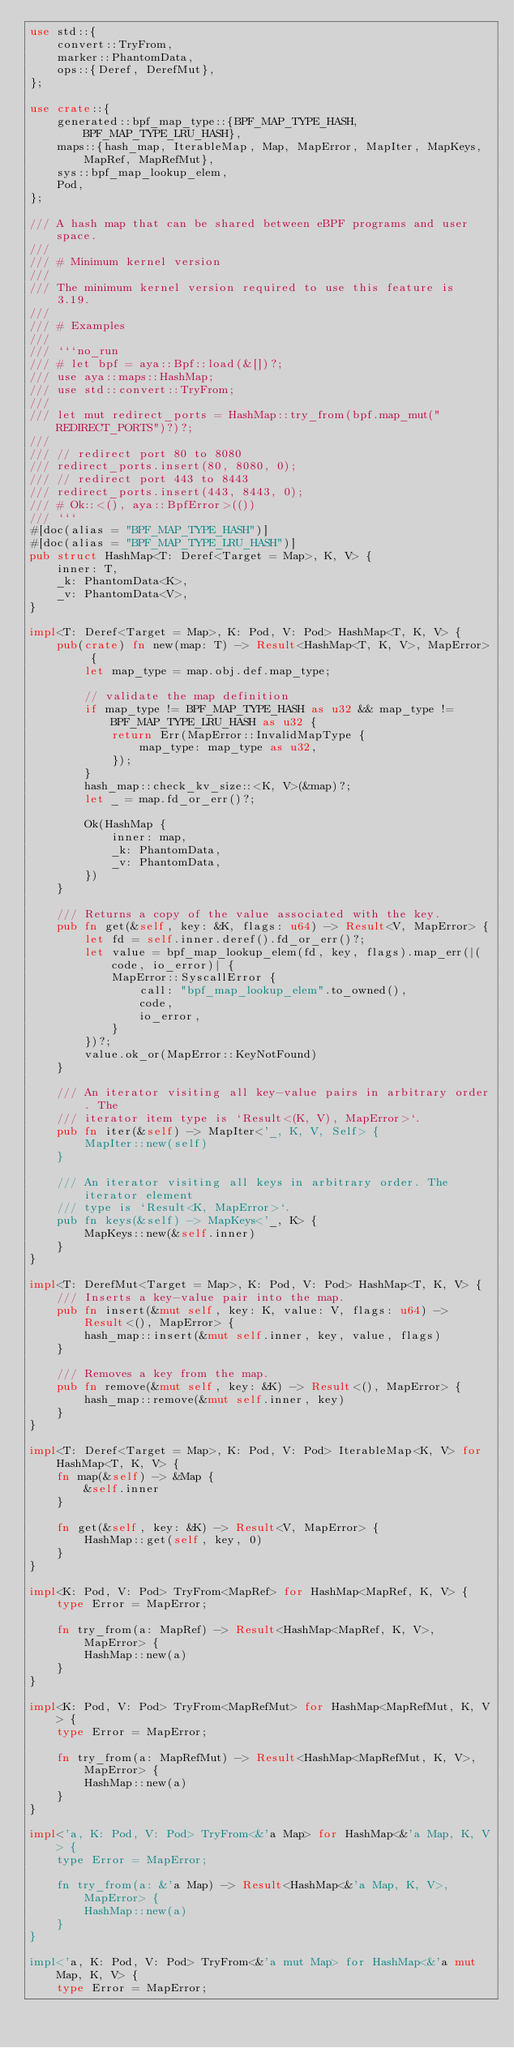Convert code to text. <code><loc_0><loc_0><loc_500><loc_500><_Rust_>use std::{
    convert::TryFrom,
    marker::PhantomData,
    ops::{Deref, DerefMut},
};

use crate::{
    generated::bpf_map_type::{BPF_MAP_TYPE_HASH, BPF_MAP_TYPE_LRU_HASH},
    maps::{hash_map, IterableMap, Map, MapError, MapIter, MapKeys, MapRef, MapRefMut},
    sys::bpf_map_lookup_elem,
    Pod,
};

/// A hash map that can be shared between eBPF programs and user space.
///
/// # Minimum kernel version
///
/// The minimum kernel version required to use this feature is 3.19.
///
/// # Examples
///
/// ```no_run
/// # let bpf = aya::Bpf::load(&[])?;
/// use aya::maps::HashMap;
/// use std::convert::TryFrom;
///
/// let mut redirect_ports = HashMap::try_from(bpf.map_mut("REDIRECT_PORTS")?)?;
///
/// // redirect port 80 to 8080
/// redirect_ports.insert(80, 8080, 0);
/// // redirect port 443 to 8443
/// redirect_ports.insert(443, 8443, 0);
/// # Ok::<(), aya::BpfError>(())
/// ```
#[doc(alias = "BPF_MAP_TYPE_HASH")]
#[doc(alias = "BPF_MAP_TYPE_LRU_HASH")]
pub struct HashMap<T: Deref<Target = Map>, K, V> {
    inner: T,
    _k: PhantomData<K>,
    _v: PhantomData<V>,
}

impl<T: Deref<Target = Map>, K: Pod, V: Pod> HashMap<T, K, V> {
    pub(crate) fn new(map: T) -> Result<HashMap<T, K, V>, MapError> {
        let map_type = map.obj.def.map_type;

        // validate the map definition
        if map_type != BPF_MAP_TYPE_HASH as u32 && map_type != BPF_MAP_TYPE_LRU_HASH as u32 {
            return Err(MapError::InvalidMapType {
                map_type: map_type as u32,
            });
        }
        hash_map::check_kv_size::<K, V>(&map)?;
        let _ = map.fd_or_err()?;

        Ok(HashMap {
            inner: map,
            _k: PhantomData,
            _v: PhantomData,
        })
    }

    /// Returns a copy of the value associated with the key.
    pub fn get(&self, key: &K, flags: u64) -> Result<V, MapError> {
        let fd = self.inner.deref().fd_or_err()?;
        let value = bpf_map_lookup_elem(fd, key, flags).map_err(|(code, io_error)| {
            MapError::SyscallError {
                call: "bpf_map_lookup_elem".to_owned(),
                code,
                io_error,
            }
        })?;
        value.ok_or(MapError::KeyNotFound)
    }

    /// An iterator visiting all key-value pairs in arbitrary order. The
    /// iterator item type is `Result<(K, V), MapError>`.
    pub fn iter(&self) -> MapIter<'_, K, V, Self> {
        MapIter::new(self)
    }

    /// An iterator visiting all keys in arbitrary order. The iterator element
    /// type is `Result<K, MapError>`.
    pub fn keys(&self) -> MapKeys<'_, K> {
        MapKeys::new(&self.inner)
    }
}

impl<T: DerefMut<Target = Map>, K: Pod, V: Pod> HashMap<T, K, V> {
    /// Inserts a key-value pair into the map.
    pub fn insert(&mut self, key: K, value: V, flags: u64) -> Result<(), MapError> {
        hash_map::insert(&mut self.inner, key, value, flags)
    }

    /// Removes a key from the map.
    pub fn remove(&mut self, key: &K) -> Result<(), MapError> {
        hash_map::remove(&mut self.inner, key)
    }
}

impl<T: Deref<Target = Map>, K: Pod, V: Pod> IterableMap<K, V> for HashMap<T, K, V> {
    fn map(&self) -> &Map {
        &self.inner
    }

    fn get(&self, key: &K) -> Result<V, MapError> {
        HashMap::get(self, key, 0)
    }
}

impl<K: Pod, V: Pod> TryFrom<MapRef> for HashMap<MapRef, K, V> {
    type Error = MapError;

    fn try_from(a: MapRef) -> Result<HashMap<MapRef, K, V>, MapError> {
        HashMap::new(a)
    }
}

impl<K: Pod, V: Pod> TryFrom<MapRefMut> for HashMap<MapRefMut, K, V> {
    type Error = MapError;

    fn try_from(a: MapRefMut) -> Result<HashMap<MapRefMut, K, V>, MapError> {
        HashMap::new(a)
    }
}

impl<'a, K: Pod, V: Pod> TryFrom<&'a Map> for HashMap<&'a Map, K, V> {
    type Error = MapError;

    fn try_from(a: &'a Map) -> Result<HashMap<&'a Map, K, V>, MapError> {
        HashMap::new(a)
    }
}

impl<'a, K: Pod, V: Pod> TryFrom<&'a mut Map> for HashMap<&'a mut Map, K, V> {
    type Error = MapError;
</code> 